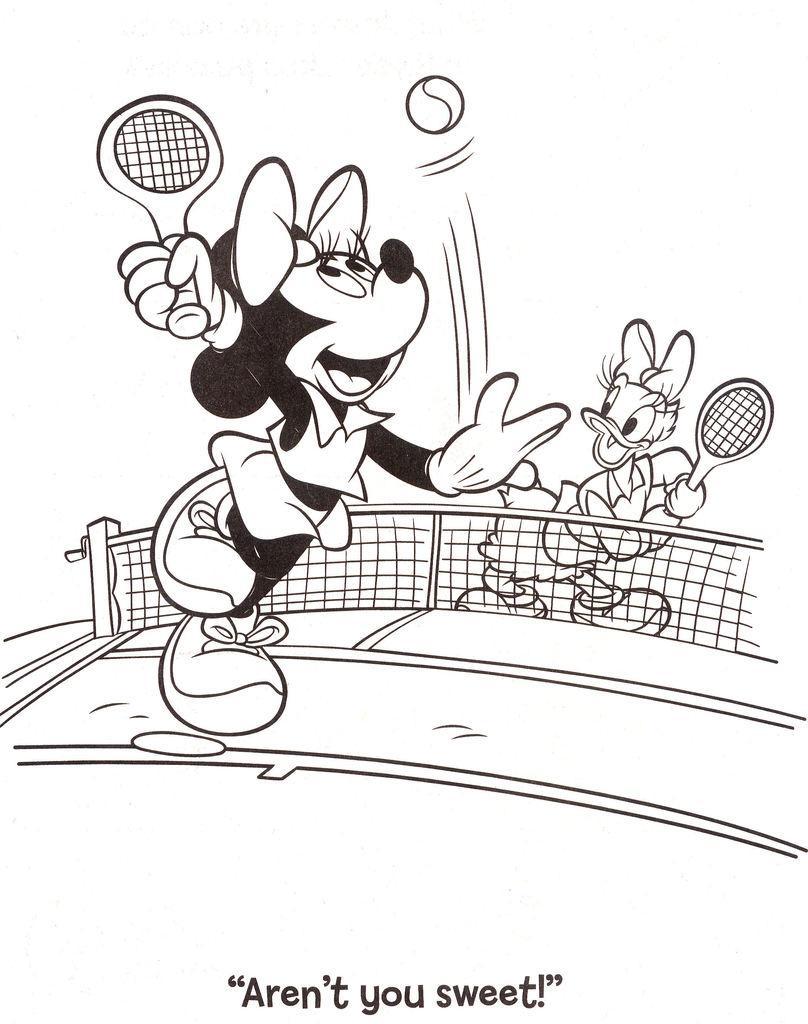Could you give a brief overview of what you see in this image? In this drawing I can see mickey mouse, donald duck, mesh, bats and ball. Something is written at the bottom of the image.   